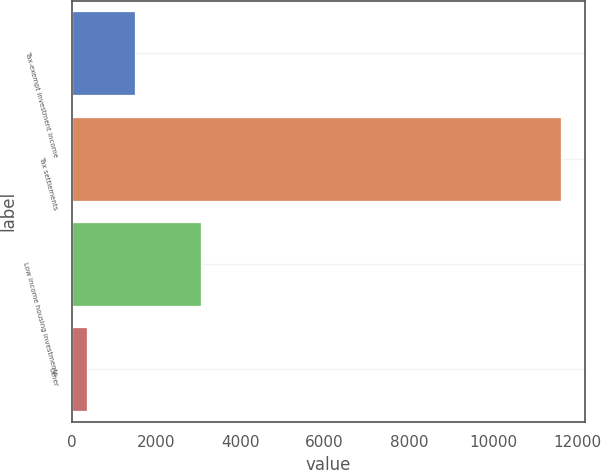Convert chart. <chart><loc_0><loc_0><loc_500><loc_500><bar_chart><fcel>Tax-exempt investment income<fcel>Tax settlements<fcel>Low income housing investments<fcel>Other<nl><fcel>1496<fcel>11607<fcel>3063<fcel>355<nl></chart> 